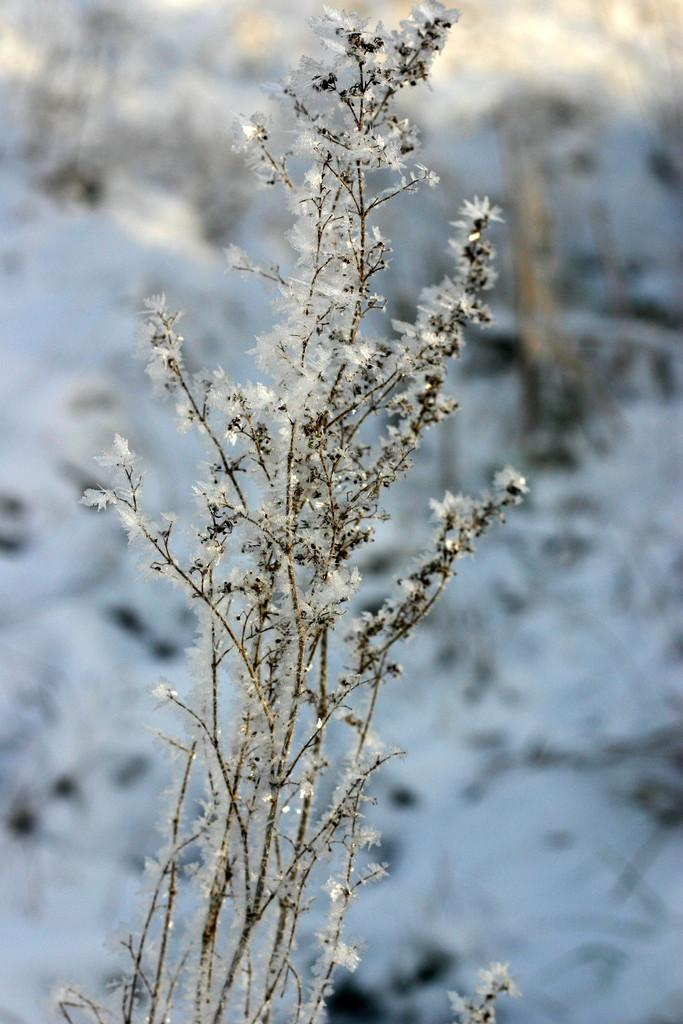What is present in the image? There is a plant in the image. Can you describe the appearance of the plant's leaves? The leaves of the plant are frosted. What type of wool is used to make the tray in the image? There is no tray or wool present in the image; it only features a plant with frosted leaves. 